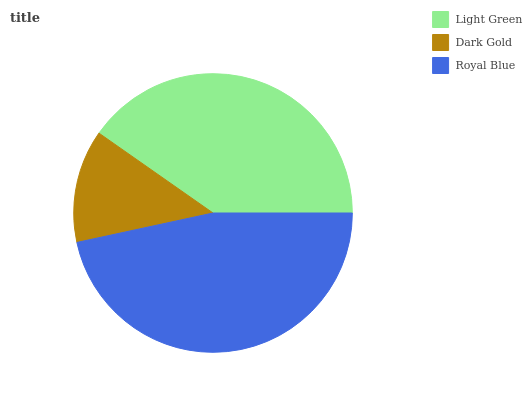Is Dark Gold the minimum?
Answer yes or no. Yes. Is Royal Blue the maximum?
Answer yes or no. Yes. Is Royal Blue the minimum?
Answer yes or no. No. Is Dark Gold the maximum?
Answer yes or no. No. Is Royal Blue greater than Dark Gold?
Answer yes or no. Yes. Is Dark Gold less than Royal Blue?
Answer yes or no. Yes. Is Dark Gold greater than Royal Blue?
Answer yes or no. No. Is Royal Blue less than Dark Gold?
Answer yes or no. No. Is Light Green the high median?
Answer yes or no. Yes. Is Light Green the low median?
Answer yes or no. Yes. Is Royal Blue the high median?
Answer yes or no. No. Is Royal Blue the low median?
Answer yes or no. No. 